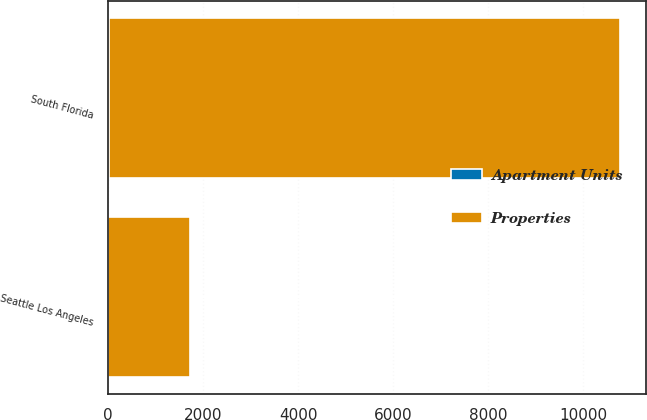Convert chart. <chart><loc_0><loc_0><loc_500><loc_500><stacked_bar_chart><ecel><fcel>South Florida<fcel>Seattle Los Angeles<nl><fcel>Apartment Units<fcel>33<fcel>8<nl><fcel>Properties<fcel>10742<fcel>1721<nl></chart> 